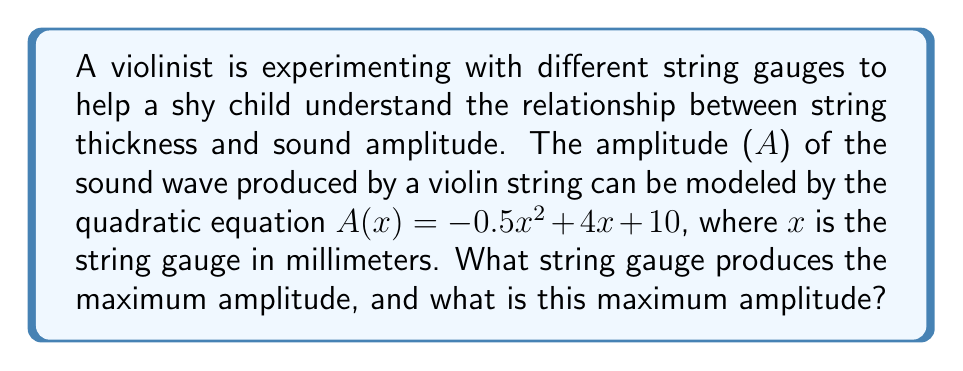Can you solve this math problem? To solve this problem, we'll follow these steps:

1) The amplitude function is a quadratic equation in the form $A(x) = -0.5x^2 + 4x + 10$

2) For a quadratic function $f(x) = ax^2 + bx + c$, the x-coordinate of the vertex is given by $x = -\frac{b}{2a}$

3) In our case, $a = -0.5$ and $b = 4$. Let's calculate the x-coordinate of the vertex:

   $x = -\frac{4}{2(-0.5)} = -\frac{4}{-1} = 4$

4) This means the maximum amplitude occurs when the string gauge is 4 mm.

5) To find the maximum amplitude, we substitute x = 4 into our original equation:

   $A(4) = -0.5(4)^2 + 4(4) + 10$
   $= -0.5(16) + 16 + 10$
   $= -8 + 16 + 10$
   $= 18$

Therefore, the maximum amplitude is 18 units.
Answer: String gauge: 4 mm; Maximum amplitude: 18 units 